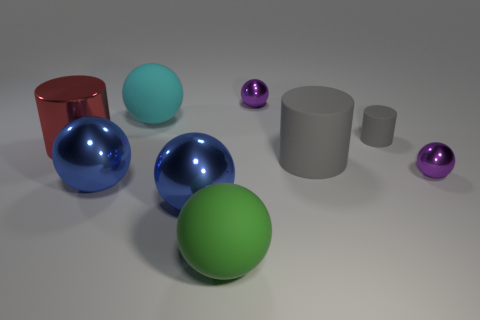Subtract all purple metal spheres. How many spheres are left? 4 Subtract all purple spheres. How many gray cylinders are left? 2 Add 1 large blue balls. How many objects exist? 10 Subtract 1 cylinders. How many cylinders are left? 2 Subtract all spheres. How many objects are left? 3 Subtract all purple balls. How many balls are left? 4 Subtract 0 gray spheres. How many objects are left? 9 Subtract all brown cylinders. Subtract all blue balls. How many cylinders are left? 3 Subtract all small cyan shiny things. Subtract all blue balls. How many objects are left? 7 Add 8 big blue objects. How many big blue objects are left? 10 